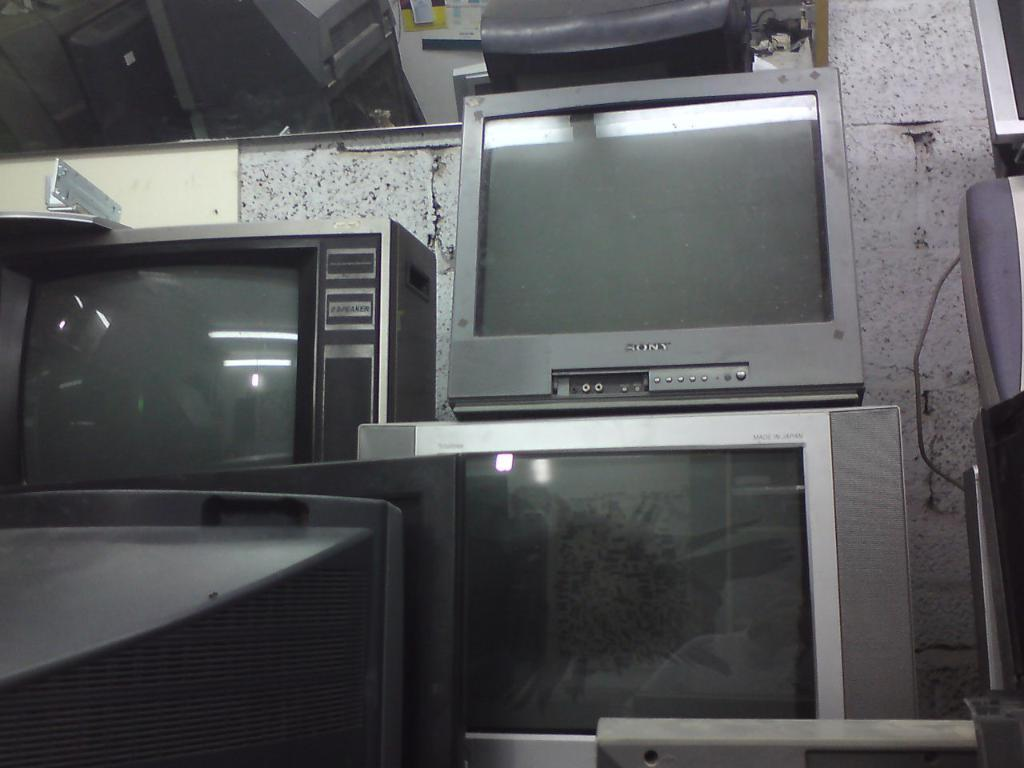Provide a one-sentence caption for the provided image. Many old televisions, one of which is Sony branded, are stacked on top of each other. 